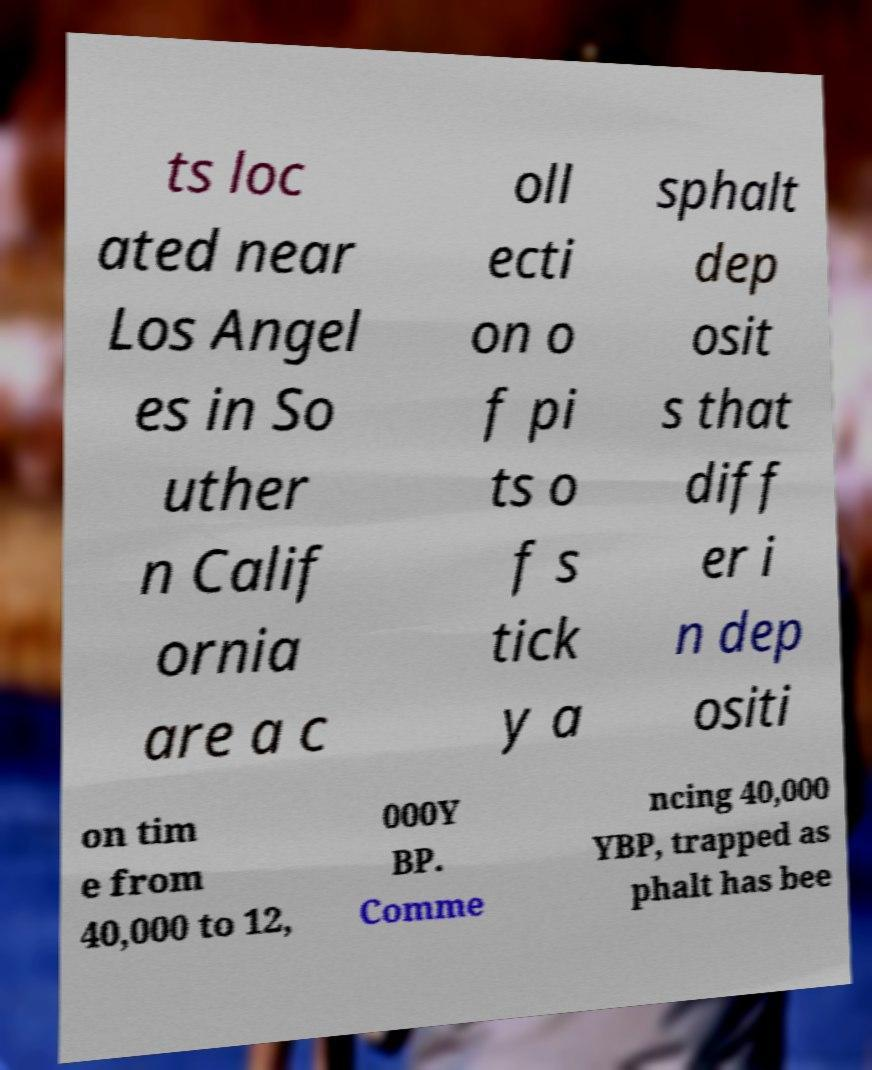For documentation purposes, I need the text within this image transcribed. Could you provide that? ts loc ated near Los Angel es in So uther n Calif ornia are a c oll ecti on o f pi ts o f s tick y a sphalt dep osit s that diff er i n dep ositi on tim e from 40,000 to 12, 000Y BP. Comme ncing 40,000 YBP, trapped as phalt has bee 